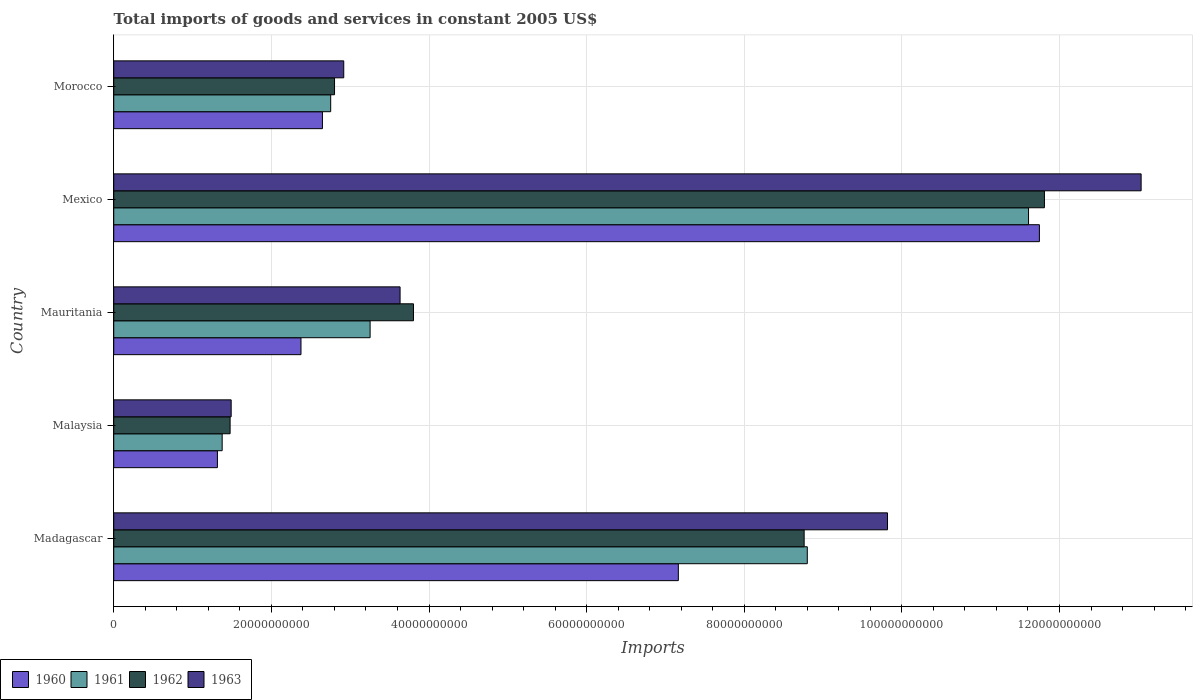How many groups of bars are there?
Offer a terse response. 5. Are the number of bars on each tick of the Y-axis equal?
Ensure brevity in your answer.  Yes. How many bars are there on the 3rd tick from the top?
Ensure brevity in your answer.  4. What is the label of the 1st group of bars from the top?
Offer a terse response. Morocco. In how many cases, is the number of bars for a given country not equal to the number of legend labels?
Provide a succinct answer. 0. What is the total imports of goods and services in 1963 in Malaysia?
Offer a terse response. 1.49e+1. Across all countries, what is the maximum total imports of goods and services in 1963?
Make the answer very short. 1.30e+11. Across all countries, what is the minimum total imports of goods and services in 1960?
Provide a short and direct response. 1.32e+1. In which country was the total imports of goods and services in 1961 minimum?
Provide a short and direct response. Malaysia. What is the total total imports of goods and services in 1963 in the graph?
Keep it short and to the point. 3.09e+11. What is the difference between the total imports of goods and services in 1962 in Malaysia and that in Mexico?
Offer a very short reply. -1.03e+11. What is the difference between the total imports of goods and services in 1960 in Morocco and the total imports of goods and services in 1962 in Mexico?
Keep it short and to the point. -9.16e+1. What is the average total imports of goods and services in 1960 per country?
Offer a terse response. 5.05e+1. What is the difference between the total imports of goods and services in 1963 and total imports of goods and services in 1960 in Madagascar?
Give a very brief answer. 2.65e+1. What is the ratio of the total imports of goods and services in 1962 in Mauritania to that in Mexico?
Make the answer very short. 0.32. What is the difference between the highest and the second highest total imports of goods and services in 1961?
Ensure brevity in your answer.  2.81e+1. What is the difference between the highest and the lowest total imports of goods and services in 1962?
Your response must be concise. 1.03e+11. In how many countries, is the total imports of goods and services in 1962 greater than the average total imports of goods and services in 1962 taken over all countries?
Keep it short and to the point. 2. Is the sum of the total imports of goods and services in 1963 in Madagascar and Mauritania greater than the maximum total imports of goods and services in 1962 across all countries?
Ensure brevity in your answer.  Yes. Is it the case that in every country, the sum of the total imports of goods and services in 1963 and total imports of goods and services in 1960 is greater than the sum of total imports of goods and services in 1962 and total imports of goods and services in 1961?
Offer a terse response. No. How many bars are there?
Keep it short and to the point. 20. Are all the bars in the graph horizontal?
Provide a short and direct response. Yes. How many countries are there in the graph?
Ensure brevity in your answer.  5. Does the graph contain grids?
Your response must be concise. Yes. How many legend labels are there?
Your answer should be very brief. 4. What is the title of the graph?
Ensure brevity in your answer.  Total imports of goods and services in constant 2005 US$. Does "1966" appear as one of the legend labels in the graph?
Your answer should be very brief. No. What is the label or title of the X-axis?
Your answer should be very brief. Imports. What is the Imports in 1960 in Madagascar?
Your answer should be very brief. 7.16e+1. What is the Imports in 1961 in Madagascar?
Your answer should be compact. 8.80e+1. What is the Imports of 1962 in Madagascar?
Provide a short and direct response. 8.76e+1. What is the Imports of 1963 in Madagascar?
Keep it short and to the point. 9.82e+1. What is the Imports in 1960 in Malaysia?
Provide a succinct answer. 1.32e+1. What is the Imports of 1961 in Malaysia?
Keep it short and to the point. 1.38e+1. What is the Imports in 1962 in Malaysia?
Your response must be concise. 1.48e+1. What is the Imports of 1963 in Malaysia?
Keep it short and to the point. 1.49e+1. What is the Imports in 1960 in Mauritania?
Make the answer very short. 2.38e+1. What is the Imports of 1961 in Mauritania?
Your answer should be very brief. 3.25e+1. What is the Imports of 1962 in Mauritania?
Keep it short and to the point. 3.80e+1. What is the Imports in 1963 in Mauritania?
Your response must be concise. 3.63e+1. What is the Imports in 1960 in Mexico?
Give a very brief answer. 1.17e+11. What is the Imports in 1961 in Mexico?
Make the answer very short. 1.16e+11. What is the Imports in 1962 in Mexico?
Ensure brevity in your answer.  1.18e+11. What is the Imports in 1963 in Mexico?
Make the answer very short. 1.30e+11. What is the Imports in 1960 in Morocco?
Provide a short and direct response. 2.65e+1. What is the Imports in 1961 in Morocco?
Your answer should be compact. 2.75e+1. What is the Imports in 1962 in Morocco?
Offer a terse response. 2.80e+1. What is the Imports in 1963 in Morocco?
Provide a succinct answer. 2.92e+1. Across all countries, what is the maximum Imports of 1960?
Offer a terse response. 1.17e+11. Across all countries, what is the maximum Imports in 1961?
Ensure brevity in your answer.  1.16e+11. Across all countries, what is the maximum Imports in 1962?
Offer a very short reply. 1.18e+11. Across all countries, what is the maximum Imports of 1963?
Your answer should be compact. 1.30e+11. Across all countries, what is the minimum Imports of 1960?
Offer a very short reply. 1.32e+1. Across all countries, what is the minimum Imports in 1961?
Make the answer very short. 1.38e+1. Across all countries, what is the minimum Imports in 1962?
Give a very brief answer. 1.48e+1. Across all countries, what is the minimum Imports in 1963?
Ensure brevity in your answer.  1.49e+1. What is the total Imports in 1960 in the graph?
Ensure brevity in your answer.  2.52e+11. What is the total Imports in 1961 in the graph?
Provide a short and direct response. 2.78e+11. What is the total Imports in 1962 in the graph?
Ensure brevity in your answer.  2.86e+11. What is the total Imports of 1963 in the graph?
Provide a short and direct response. 3.09e+11. What is the difference between the Imports in 1960 in Madagascar and that in Malaysia?
Your response must be concise. 5.85e+1. What is the difference between the Imports of 1961 in Madagascar and that in Malaysia?
Your response must be concise. 7.42e+1. What is the difference between the Imports in 1962 in Madagascar and that in Malaysia?
Your response must be concise. 7.28e+1. What is the difference between the Imports of 1963 in Madagascar and that in Malaysia?
Provide a short and direct response. 8.33e+1. What is the difference between the Imports in 1960 in Madagascar and that in Mauritania?
Provide a short and direct response. 4.79e+1. What is the difference between the Imports of 1961 in Madagascar and that in Mauritania?
Your response must be concise. 5.55e+1. What is the difference between the Imports of 1962 in Madagascar and that in Mauritania?
Make the answer very short. 4.96e+1. What is the difference between the Imports of 1963 in Madagascar and that in Mauritania?
Your answer should be compact. 6.18e+1. What is the difference between the Imports of 1960 in Madagascar and that in Mexico?
Offer a very short reply. -4.58e+1. What is the difference between the Imports of 1961 in Madagascar and that in Mexico?
Offer a terse response. -2.81e+1. What is the difference between the Imports of 1962 in Madagascar and that in Mexico?
Give a very brief answer. -3.05e+1. What is the difference between the Imports in 1963 in Madagascar and that in Mexico?
Provide a succinct answer. -3.22e+1. What is the difference between the Imports of 1960 in Madagascar and that in Morocco?
Ensure brevity in your answer.  4.52e+1. What is the difference between the Imports of 1961 in Madagascar and that in Morocco?
Your answer should be very brief. 6.05e+1. What is the difference between the Imports in 1962 in Madagascar and that in Morocco?
Your response must be concise. 5.96e+1. What is the difference between the Imports of 1963 in Madagascar and that in Morocco?
Your response must be concise. 6.90e+1. What is the difference between the Imports of 1960 in Malaysia and that in Mauritania?
Your answer should be very brief. -1.06e+1. What is the difference between the Imports in 1961 in Malaysia and that in Mauritania?
Make the answer very short. -1.88e+1. What is the difference between the Imports in 1962 in Malaysia and that in Mauritania?
Make the answer very short. -2.33e+1. What is the difference between the Imports of 1963 in Malaysia and that in Mauritania?
Your answer should be compact. -2.14e+1. What is the difference between the Imports in 1960 in Malaysia and that in Mexico?
Keep it short and to the point. -1.04e+11. What is the difference between the Imports of 1961 in Malaysia and that in Mexico?
Your answer should be very brief. -1.02e+11. What is the difference between the Imports in 1962 in Malaysia and that in Mexico?
Provide a short and direct response. -1.03e+11. What is the difference between the Imports in 1963 in Malaysia and that in Mexico?
Ensure brevity in your answer.  -1.15e+11. What is the difference between the Imports of 1960 in Malaysia and that in Morocco?
Your answer should be compact. -1.33e+1. What is the difference between the Imports in 1961 in Malaysia and that in Morocco?
Your answer should be compact. -1.38e+1. What is the difference between the Imports in 1962 in Malaysia and that in Morocco?
Make the answer very short. -1.33e+1. What is the difference between the Imports in 1963 in Malaysia and that in Morocco?
Offer a terse response. -1.43e+1. What is the difference between the Imports in 1960 in Mauritania and that in Mexico?
Provide a short and direct response. -9.37e+1. What is the difference between the Imports in 1961 in Mauritania and that in Mexico?
Provide a short and direct response. -8.35e+1. What is the difference between the Imports of 1962 in Mauritania and that in Mexico?
Give a very brief answer. -8.01e+1. What is the difference between the Imports in 1963 in Mauritania and that in Mexico?
Your answer should be compact. -9.40e+1. What is the difference between the Imports of 1960 in Mauritania and that in Morocco?
Your answer should be compact. -2.72e+09. What is the difference between the Imports of 1961 in Mauritania and that in Morocco?
Offer a terse response. 5.00e+09. What is the difference between the Imports of 1962 in Mauritania and that in Morocco?
Provide a short and direct response. 1.00e+1. What is the difference between the Imports in 1963 in Mauritania and that in Morocco?
Give a very brief answer. 7.15e+09. What is the difference between the Imports in 1960 in Mexico and that in Morocco?
Make the answer very short. 9.10e+1. What is the difference between the Imports in 1961 in Mexico and that in Morocco?
Provide a short and direct response. 8.85e+1. What is the difference between the Imports of 1962 in Mexico and that in Morocco?
Provide a succinct answer. 9.01e+1. What is the difference between the Imports of 1963 in Mexico and that in Morocco?
Your answer should be very brief. 1.01e+11. What is the difference between the Imports in 1960 in Madagascar and the Imports in 1961 in Malaysia?
Your answer should be compact. 5.79e+1. What is the difference between the Imports in 1960 in Madagascar and the Imports in 1962 in Malaysia?
Your answer should be compact. 5.69e+1. What is the difference between the Imports in 1960 in Madagascar and the Imports in 1963 in Malaysia?
Make the answer very short. 5.67e+1. What is the difference between the Imports of 1961 in Madagascar and the Imports of 1962 in Malaysia?
Offer a very short reply. 7.32e+1. What is the difference between the Imports of 1961 in Madagascar and the Imports of 1963 in Malaysia?
Your answer should be compact. 7.31e+1. What is the difference between the Imports in 1962 in Madagascar and the Imports in 1963 in Malaysia?
Your response must be concise. 7.27e+1. What is the difference between the Imports of 1960 in Madagascar and the Imports of 1961 in Mauritania?
Your answer should be very brief. 3.91e+1. What is the difference between the Imports in 1960 in Madagascar and the Imports in 1962 in Mauritania?
Provide a short and direct response. 3.36e+1. What is the difference between the Imports of 1960 in Madagascar and the Imports of 1963 in Mauritania?
Your answer should be compact. 3.53e+1. What is the difference between the Imports in 1961 in Madagascar and the Imports in 1962 in Mauritania?
Offer a very short reply. 5.00e+1. What is the difference between the Imports of 1961 in Madagascar and the Imports of 1963 in Mauritania?
Provide a short and direct response. 5.17e+1. What is the difference between the Imports in 1962 in Madagascar and the Imports in 1963 in Mauritania?
Make the answer very short. 5.13e+1. What is the difference between the Imports in 1960 in Madagascar and the Imports in 1961 in Mexico?
Your answer should be compact. -4.44e+1. What is the difference between the Imports in 1960 in Madagascar and the Imports in 1962 in Mexico?
Keep it short and to the point. -4.65e+1. What is the difference between the Imports of 1960 in Madagascar and the Imports of 1963 in Mexico?
Provide a short and direct response. -5.87e+1. What is the difference between the Imports of 1961 in Madagascar and the Imports of 1962 in Mexico?
Your response must be concise. -3.01e+1. What is the difference between the Imports of 1961 in Madagascar and the Imports of 1963 in Mexico?
Provide a succinct answer. -4.24e+1. What is the difference between the Imports in 1962 in Madagascar and the Imports in 1963 in Mexico?
Your answer should be compact. -4.28e+1. What is the difference between the Imports in 1960 in Madagascar and the Imports in 1961 in Morocco?
Keep it short and to the point. 4.41e+1. What is the difference between the Imports in 1960 in Madagascar and the Imports in 1962 in Morocco?
Provide a short and direct response. 4.36e+1. What is the difference between the Imports in 1960 in Madagascar and the Imports in 1963 in Morocco?
Keep it short and to the point. 4.25e+1. What is the difference between the Imports in 1961 in Madagascar and the Imports in 1962 in Morocco?
Your response must be concise. 6.00e+1. What is the difference between the Imports in 1961 in Madagascar and the Imports in 1963 in Morocco?
Your response must be concise. 5.88e+1. What is the difference between the Imports of 1962 in Madagascar and the Imports of 1963 in Morocco?
Give a very brief answer. 5.84e+1. What is the difference between the Imports of 1960 in Malaysia and the Imports of 1961 in Mauritania?
Give a very brief answer. -1.94e+1. What is the difference between the Imports of 1960 in Malaysia and the Imports of 1962 in Mauritania?
Offer a very short reply. -2.49e+1. What is the difference between the Imports in 1960 in Malaysia and the Imports in 1963 in Mauritania?
Make the answer very short. -2.32e+1. What is the difference between the Imports of 1961 in Malaysia and the Imports of 1962 in Mauritania?
Your answer should be compact. -2.43e+1. What is the difference between the Imports of 1961 in Malaysia and the Imports of 1963 in Mauritania?
Provide a succinct answer. -2.26e+1. What is the difference between the Imports in 1962 in Malaysia and the Imports in 1963 in Mauritania?
Your response must be concise. -2.16e+1. What is the difference between the Imports in 1960 in Malaysia and the Imports in 1961 in Mexico?
Your answer should be very brief. -1.03e+11. What is the difference between the Imports of 1960 in Malaysia and the Imports of 1962 in Mexico?
Give a very brief answer. -1.05e+11. What is the difference between the Imports of 1960 in Malaysia and the Imports of 1963 in Mexico?
Ensure brevity in your answer.  -1.17e+11. What is the difference between the Imports of 1961 in Malaysia and the Imports of 1962 in Mexico?
Provide a short and direct response. -1.04e+11. What is the difference between the Imports of 1961 in Malaysia and the Imports of 1963 in Mexico?
Give a very brief answer. -1.17e+11. What is the difference between the Imports in 1962 in Malaysia and the Imports in 1963 in Mexico?
Your response must be concise. -1.16e+11. What is the difference between the Imports of 1960 in Malaysia and the Imports of 1961 in Morocco?
Give a very brief answer. -1.44e+1. What is the difference between the Imports of 1960 in Malaysia and the Imports of 1962 in Morocco?
Your answer should be very brief. -1.49e+1. What is the difference between the Imports of 1960 in Malaysia and the Imports of 1963 in Morocco?
Provide a short and direct response. -1.60e+1. What is the difference between the Imports of 1961 in Malaysia and the Imports of 1962 in Morocco?
Your answer should be very brief. -1.43e+1. What is the difference between the Imports of 1961 in Malaysia and the Imports of 1963 in Morocco?
Keep it short and to the point. -1.54e+1. What is the difference between the Imports of 1962 in Malaysia and the Imports of 1963 in Morocco?
Your response must be concise. -1.44e+1. What is the difference between the Imports in 1960 in Mauritania and the Imports in 1961 in Mexico?
Give a very brief answer. -9.23e+1. What is the difference between the Imports in 1960 in Mauritania and the Imports in 1962 in Mexico?
Offer a terse response. -9.43e+1. What is the difference between the Imports in 1960 in Mauritania and the Imports in 1963 in Mexico?
Make the answer very short. -1.07e+11. What is the difference between the Imports of 1961 in Mauritania and the Imports of 1962 in Mexico?
Make the answer very short. -8.56e+1. What is the difference between the Imports of 1961 in Mauritania and the Imports of 1963 in Mexico?
Provide a short and direct response. -9.78e+1. What is the difference between the Imports in 1962 in Mauritania and the Imports in 1963 in Mexico?
Your answer should be very brief. -9.23e+1. What is the difference between the Imports of 1960 in Mauritania and the Imports of 1961 in Morocco?
Offer a terse response. -3.77e+09. What is the difference between the Imports in 1960 in Mauritania and the Imports in 1962 in Morocco?
Your response must be concise. -4.26e+09. What is the difference between the Imports in 1960 in Mauritania and the Imports in 1963 in Morocco?
Your response must be concise. -5.43e+09. What is the difference between the Imports of 1961 in Mauritania and the Imports of 1962 in Morocco?
Your answer should be compact. 4.51e+09. What is the difference between the Imports in 1961 in Mauritania and the Imports in 1963 in Morocco?
Your response must be concise. 3.34e+09. What is the difference between the Imports of 1962 in Mauritania and the Imports of 1963 in Morocco?
Provide a succinct answer. 8.85e+09. What is the difference between the Imports in 1960 in Mexico and the Imports in 1961 in Morocco?
Ensure brevity in your answer.  8.99e+1. What is the difference between the Imports in 1960 in Mexico and the Imports in 1962 in Morocco?
Your answer should be very brief. 8.94e+1. What is the difference between the Imports in 1960 in Mexico and the Imports in 1963 in Morocco?
Keep it short and to the point. 8.83e+1. What is the difference between the Imports of 1961 in Mexico and the Imports of 1962 in Morocco?
Offer a terse response. 8.81e+1. What is the difference between the Imports of 1961 in Mexico and the Imports of 1963 in Morocco?
Provide a short and direct response. 8.69e+1. What is the difference between the Imports of 1962 in Mexico and the Imports of 1963 in Morocco?
Offer a very short reply. 8.89e+1. What is the average Imports in 1960 per country?
Keep it short and to the point. 5.05e+1. What is the average Imports of 1961 per country?
Make the answer very short. 5.56e+1. What is the average Imports of 1962 per country?
Your answer should be very brief. 5.73e+1. What is the average Imports in 1963 per country?
Offer a very short reply. 6.18e+1. What is the difference between the Imports in 1960 and Imports in 1961 in Madagascar?
Your response must be concise. -1.64e+1. What is the difference between the Imports in 1960 and Imports in 1962 in Madagascar?
Ensure brevity in your answer.  -1.60e+1. What is the difference between the Imports in 1960 and Imports in 1963 in Madagascar?
Keep it short and to the point. -2.65e+1. What is the difference between the Imports in 1961 and Imports in 1962 in Madagascar?
Your response must be concise. 3.99e+08. What is the difference between the Imports in 1961 and Imports in 1963 in Madagascar?
Offer a very short reply. -1.02e+1. What is the difference between the Imports of 1962 and Imports of 1963 in Madagascar?
Offer a very short reply. -1.06e+1. What is the difference between the Imports of 1960 and Imports of 1961 in Malaysia?
Provide a succinct answer. -6.03e+08. What is the difference between the Imports in 1960 and Imports in 1962 in Malaysia?
Your answer should be very brief. -1.61e+09. What is the difference between the Imports in 1960 and Imports in 1963 in Malaysia?
Make the answer very short. -1.74e+09. What is the difference between the Imports in 1961 and Imports in 1962 in Malaysia?
Make the answer very short. -1.01e+09. What is the difference between the Imports of 1961 and Imports of 1963 in Malaysia?
Offer a terse response. -1.14e+09. What is the difference between the Imports of 1962 and Imports of 1963 in Malaysia?
Make the answer very short. -1.35e+08. What is the difference between the Imports in 1960 and Imports in 1961 in Mauritania?
Make the answer very short. -8.77e+09. What is the difference between the Imports in 1960 and Imports in 1962 in Mauritania?
Provide a short and direct response. -1.43e+1. What is the difference between the Imports of 1960 and Imports of 1963 in Mauritania?
Your answer should be compact. -1.26e+1. What is the difference between the Imports of 1961 and Imports of 1962 in Mauritania?
Provide a succinct answer. -5.50e+09. What is the difference between the Imports of 1961 and Imports of 1963 in Mauritania?
Give a very brief answer. -3.80e+09. What is the difference between the Imports in 1962 and Imports in 1963 in Mauritania?
Give a very brief answer. 1.70e+09. What is the difference between the Imports in 1960 and Imports in 1961 in Mexico?
Make the answer very short. 1.38e+09. What is the difference between the Imports of 1960 and Imports of 1962 in Mexico?
Your response must be concise. -6.38e+08. What is the difference between the Imports of 1960 and Imports of 1963 in Mexico?
Provide a short and direct response. -1.29e+1. What is the difference between the Imports in 1961 and Imports in 1962 in Mexico?
Your answer should be very brief. -2.02e+09. What is the difference between the Imports in 1961 and Imports in 1963 in Mexico?
Keep it short and to the point. -1.43e+1. What is the difference between the Imports of 1962 and Imports of 1963 in Mexico?
Your response must be concise. -1.23e+1. What is the difference between the Imports of 1960 and Imports of 1961 in Morocco?
Ensure brevity in your answer.  -1.05e+09. What is the difference between the Imports in 1960 and Imports in 1962 in Morocco?
Make the answer very short. -1.54e+09. What is the difference between the Imports in 1960 and Imports in 1963 in Morocco?
Make the answer very short. -2.70e+09. What is the difference between the Imports of 1961 and Imports of 1962 in Morocco?
Make the answer very short. -4.88e+08. What is the difference between the Imports of 1961 and Imports of 1963 in Morocco?
Make the answer very short. -1.66e+09. What is the difference between the Imports in 1962 and Imports in 1963 in Morocco?
Your response must be concise. -1.17e+09. What is the ratio of the Imports in 1960 in Madagascar to that in Malaysia?
Make the answer very short. 5.45. What is the ratio of the Imports in 1961 in Madagascar to that in Malaysia?
Provide a succinct answer. 6.4. What is the ratio of the Imports of 1962 in Madagascar to that in Malaysia?
Keep it short and to the point. 5.93. What is the ratio of the Imports of 1963 in Madagascar to that in Malaysia?
Provide a succinct answer. 6.59. What is the ratio of the Imports of 1960 in Madagascar to that in Mauritania?
Keep it short and to the point. 3.02. What is the ratio of the Imports of 1961 in Madagascar to that in Mauritania?
Keep it short and to the point. 2.71. What is the ratio of the Imports in 1962 in Madagascar to that in Mauritania?
Keep it short and to the point. 2.3. What is the ratio of the Imports of 1963 in Madagascar to that in Mauritania?
Make the answer very short. 2.7. What is the ratio of the Imports of 1960 in Madagascar to that in Mexico?
Offer a very short reply. 0.61. What is the ratio of the Imports in 1961 in Madagascar to that in Mexico?
Your answer should be compact. 0.76. What is the ratio of the Imports of 1962 in Madagascar to that in Mexico?
Keep it short and to the point. 0.74. What is the ratio of the Imports of 1963 in Madagascar to that in Mexico?
Offer a terse response. 0.75. What is the ratio of the Imports of 1960 in Madagascar to that in Morocco?
Offer a terse response. 2.71. What is the ratio of the Imports in 1961 in Madagascar to that in Morocco?
Keep it short and to the point. 3.2. What is the ratio of the Imports in 1962 in Madagascar to that in Morocco?
Give a very brief answer. 3.13. What is the ratio of the Imports of 1963 in Madagascar to that in Morocco?
Provide a succinct answer. 3.36. What is the ratio of the Imports of 1960 in Malaysia to that in Mauritania?
Your answer should be compact. 0.55. What is the ratio of the Imports in 1961 in Malaysia to that in Mauritania?
Offer a very short reply. 0.42. What is the ratio of the Imports in 1962 in Malaysia to that in Mauritania?
Your answer should be compact. 0.39. What is the ratio of the Imports of 1963 in Malaysia to that in Mauritania?
Offer a terse response. 0.41. What is the ratio of the Imports in 1960 in Malaysia to that in Mexico?
Make the answer very short. 0.11. What is the ratio of the Imports of 1961 in Malaysia to that in Mexico?
Offer a terse response. 0.12. What is the ratio of the Imports of 1962 in Malaysia to that in Mexico?
Offer a terse response. 0.12. What is the ratio of the Imports in 1963 in Malaysia to that in Mexico?
Offer a very short reply. 0.11. What is the ratio of the Imports in 1960 in Malaysia to that in Morocco?
Offer a terse response. 0.5. What is the ratio of the Imports in 1961 in Malaysia to that in Morocco?
Your response must be concise. 0.5. What is the ratio of the Imports of 1962 in Malaysia to that in Morocco?
Your answer should be compact. 0.53. What is the ratio of the Imports in 1963 in Malaysia to that in Morocco?
Provide a short and direct response. 0.51. What is the ratio of the Imports in 1960 in Mauritania to that in Mexico?
Offer a very short reply. 0.2. What is the ratio of the Imports in 1961 in Mauritania to that in Mexico?
Make the answer very short. 0.28. What is the ratio of the Imports in 1962 in Mauritania to that in Mexico?
Offer a very short reply. 0.32. What is the ratio of the Imports of 1963 in Mauritania to that in Mexico?
Your answer should be very brief. 0.28. What is the ratio of the Imports in 1960 in Mauritania to that in Morocco?
Your answer should be very brief. 0.9. What is the ratio of the Imports of 1961 in Mauritania to that in Morocco?
Offer a terse response. 1.18. What is the ratio of the Imports of 1962 in Mauritania to that in Morocco?
Offer a terse response. 1.36. What is the ratio of the Imports in 1963 in Mauritania to that in Morocco?
Offer a very short reply. 1.24. What is the ratio of the Imports in 1960 in Mexico to that in Morocco?
Your response must be concise. 4.44. What is the ratio of the Imports in 1961 in Mexico to that in Morocco?
Keep it short and to the point. 4.22. What is the ratio of the Imports in 1962 in Mexico to that in Morocco?
Provide a succinct answer. 4.22. What is the ratio of the Imports of 1963 in Mexico to that in Morocco?
Your answer should be compact. 4.47. What is the difference between the highest and the second highest Imports of 1960?
Your response must be concise. 4.58e+1. What is the difference between the highest and the second highest Imports of 1961?
Offer a very short reply. 2.81e+1. What is the difference between the highest and the second highest Imports in 1962?
Give a very brief answer. 3.05e+1. What is the difference between the highest and the second highest Imports of 1963?
Offer a terse response. 3.22e+1. What is the difference between the highest and the lowest Imports in 1960?
Give a very brief answer. 1.04e+11. What is the difference between the highest and the lowest Imports in 1961?
Provide a succinct answer. 1.02e+11. What is the difference between the highest and the lowest Imports in 1962?
Provide a succinct answer. 1.03e+11. What is the difference between the highest and the lowest Imports of 1963?
Your response must be concise. 1.15e+11. 